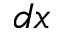Convert formula to latex. <formula><loc_0><loc_0><loc_500><loc_500>d x</formula> 